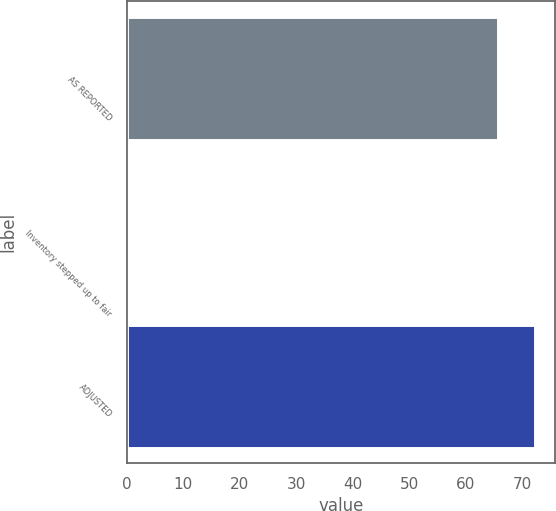Convert chart to OTSL. <chart><loc_0><loc_0><loc_500><loc_500><bar_chart><fcel>AS REPORTED<fcel>Inventory stepped up to fair<fcel>ADJUSTED<nl><fcel>65.7<fcel>0.3<fcel>72.27<nl></chart> 